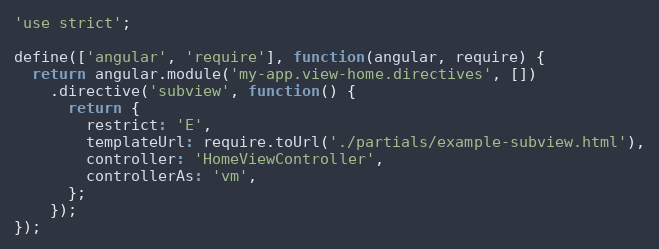Convert code to text. <code><loc_0><loc_0><loc_500><loc_500><_JavaScript_>'use strict';

define(['angular', 'require'], function(angular, require) {
  return angular.module('my-app.view-home.directives', [])
    .directive('subview', function() {
      return {
        restrict: 'E',
        templateUrl: require.toUrl('./partials/example-subview.html'),
        controller: 'HomeViewController',
        controllerAs: 'vm',
      };
    });
});
</code> 